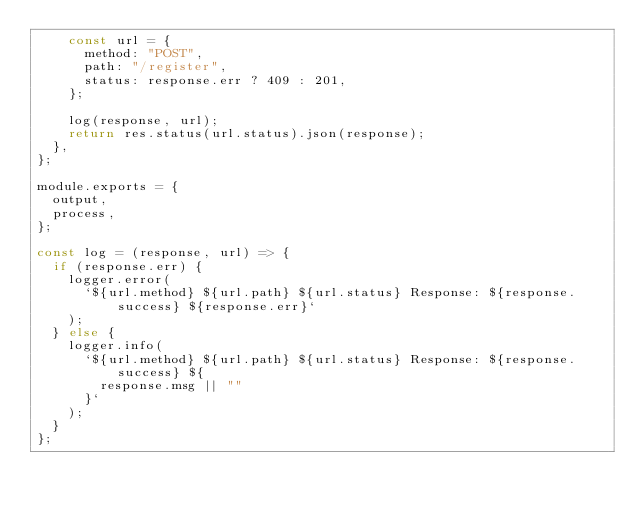<code> <loc_0><loc_0><loc_500><loc_500><_JavaScript_>    const url = {
      method: "POST",
      path: "/register",
      status: response.err ? 409 : 201,
    };

    log(response, url);
    return res.status(url.status).json(response);
  },
};

module.exports = {
  output,
  process,
};

const log = (response, url) => {
  if (response.err) {
    logger.error(
      `${url.method} ${url.path} ${url.status} Response: ${response.success} ${response.err}`
    );
  } else {
    logger.info(
      `${url.method} ${url.path} ${url.status} Response: ${response.success} ${
        response.msg || ""
      }`
    );
  }
};
</code> 